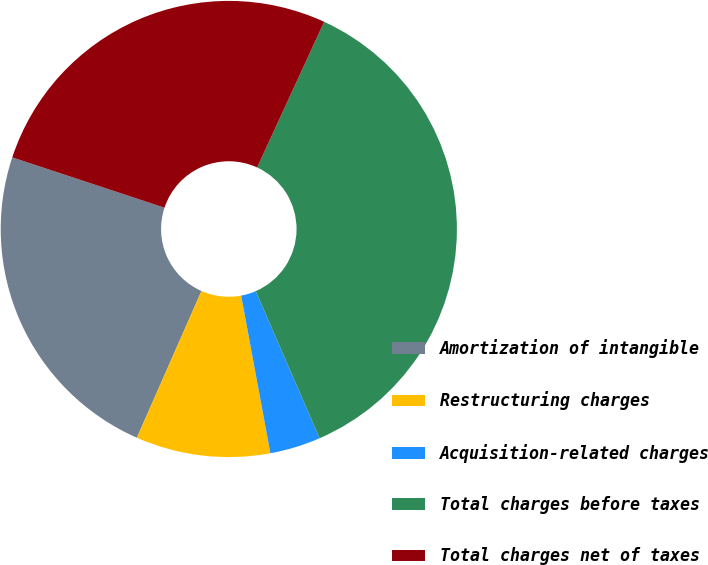<chart> <loc_0><loc_0><loc_500><loc_500><pie_chart><fcel>Amortization of intangible<fcel>Restructuring charges<fcel>Acquisition-related charges<fcel>Total charges before taxes<fcel>Total charges net of taxes<nl><fcel>23.48%<fcel>9.52%<fcel>3.6%<fcel>36.61%<fcel>26.78%<nl></chart> 